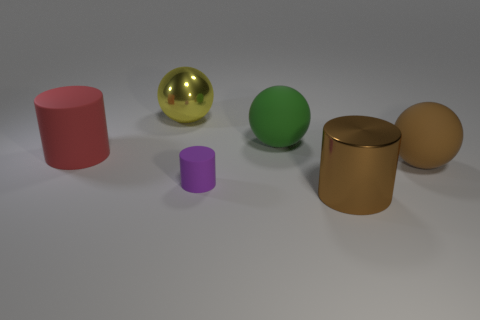Are there more shiny cylinders behind the yellow shiny thing than red things? no 